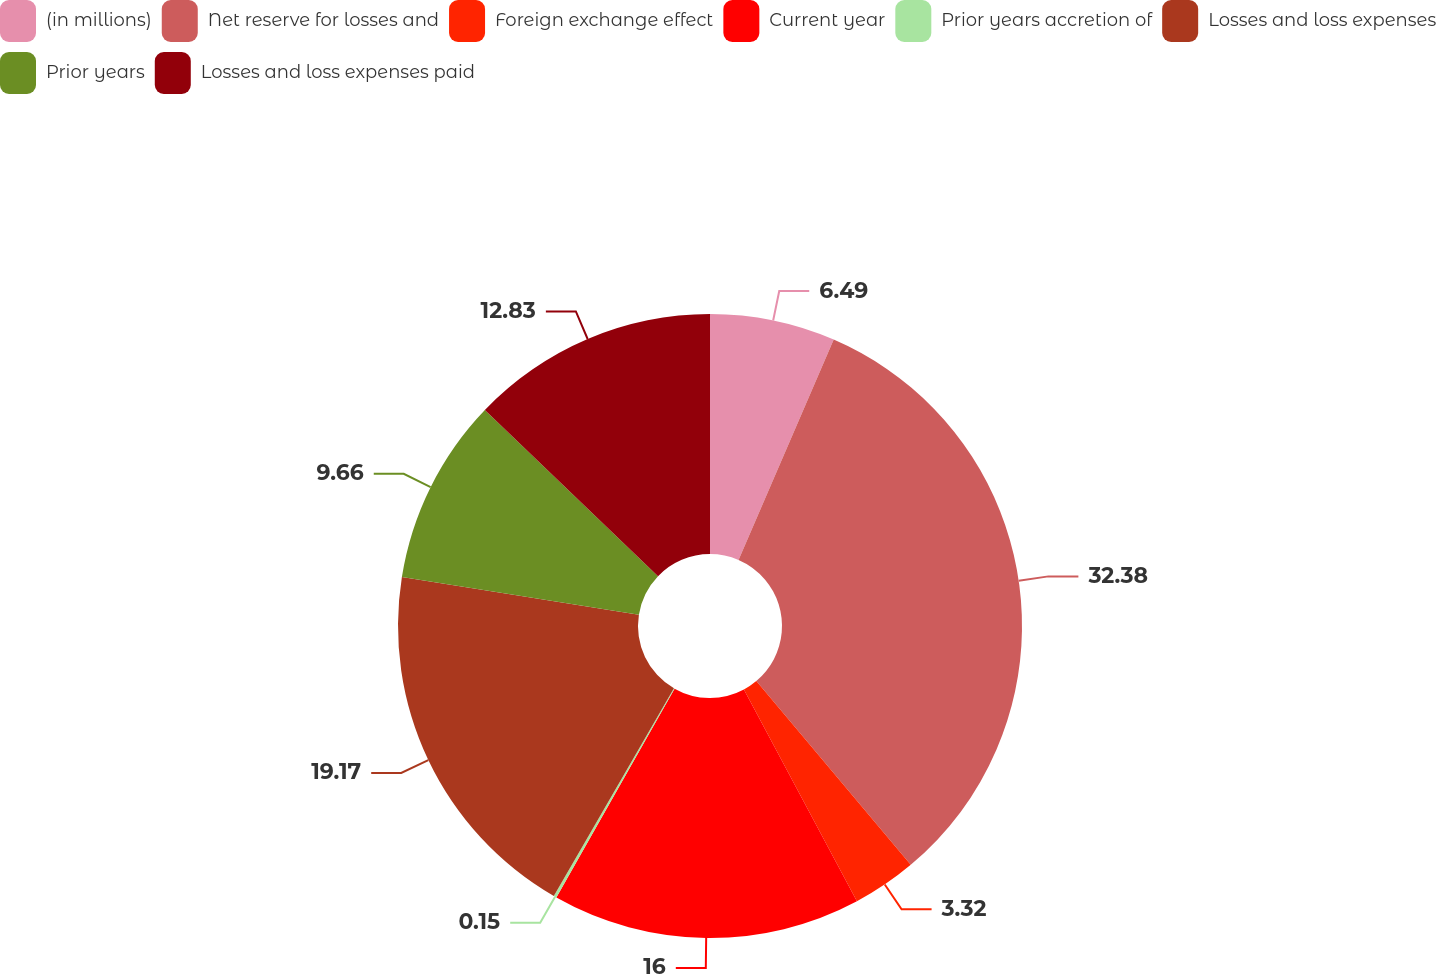Convert chart to OTSL. <chart><loc_0><loc_0><loc_500><loc_500><pie_chart><fcel>(in millions)<fcel>Net reserve for losses and<fcel>Foreign exchange effect<fcel>Current year<fcel>Prior years accretion of<fcel>Losses and loss expenses<fcel>Prior years<fcel>Losses and loss expenses paid<nl><fcel>6.49%<fcel>32.39%<fcel>3.32%<fcel>16.0%<fcel>0.15%<fcel>19.17%<fcel>9.66%<fcel>12.83%<nl></chart> 